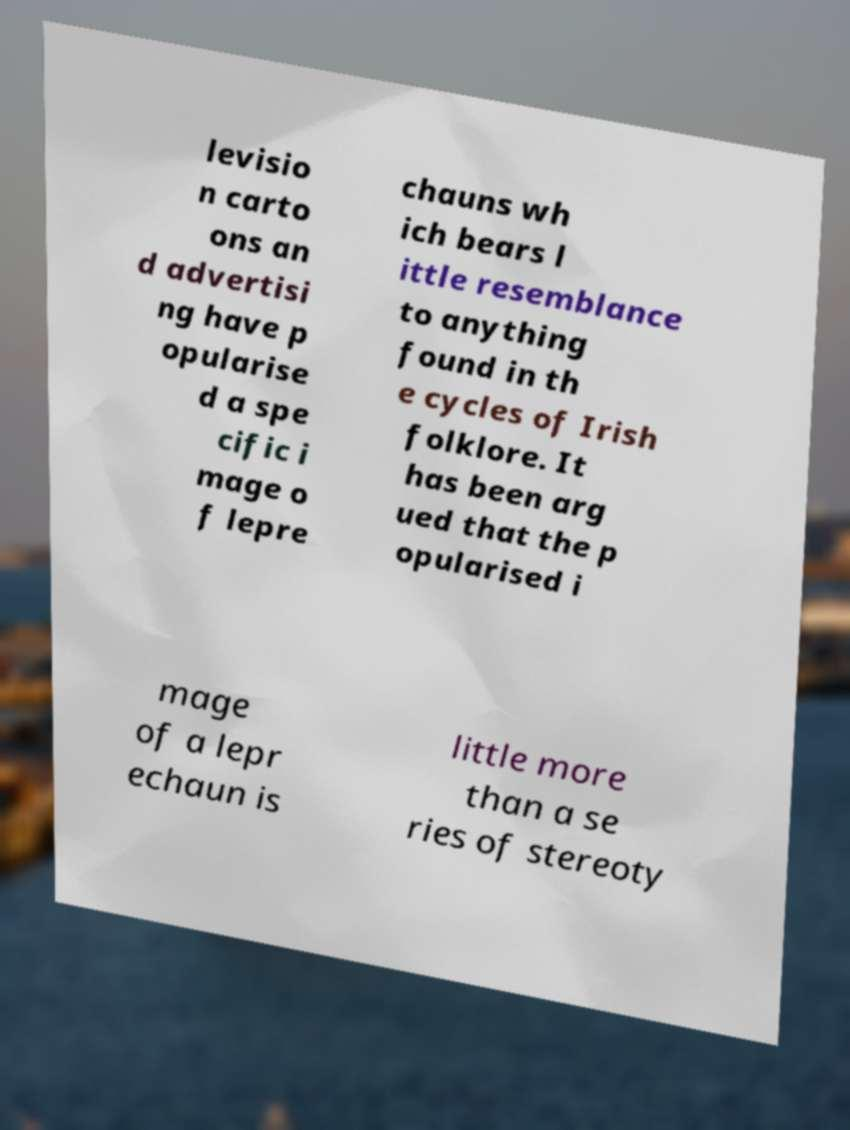What messages or text are displayed in this image? I need them in a readable, typed format. levisio n carto ons an d advertisi ng have p opularise d a spe cific i mage o f lepre chauns wh ich bears l ittle resemblance to anything found in th e cycles of Irish folklore. It has been arg ued that the p opularised i mage of a lepr echaun is little more than a se ries of stereoty 